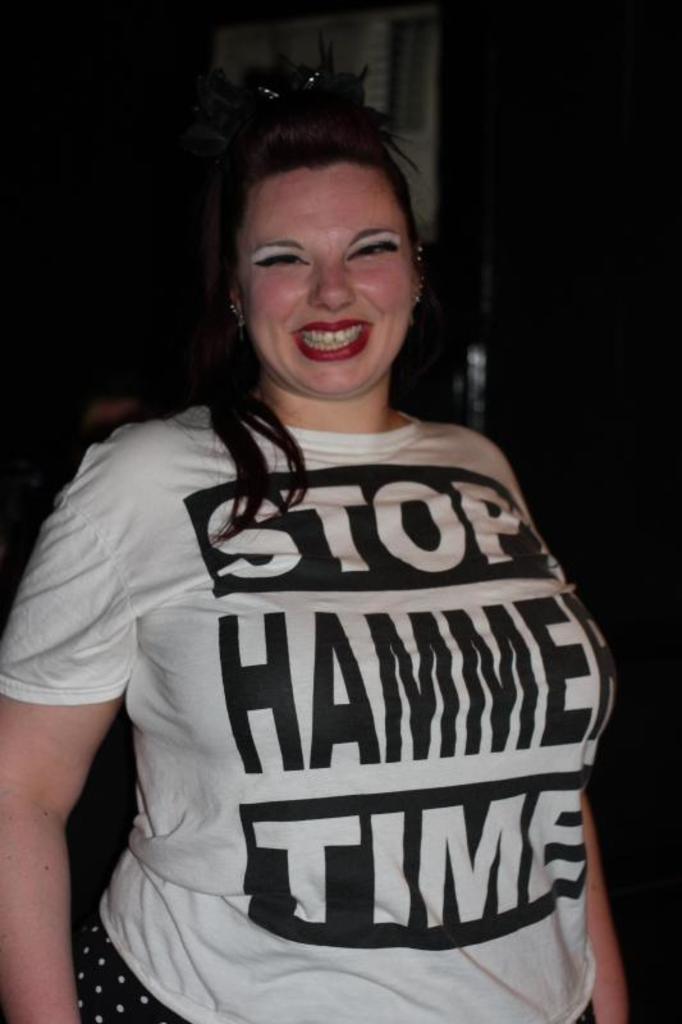What is the first word on the t-shirt?
Keep it short and to the point. Stop. 